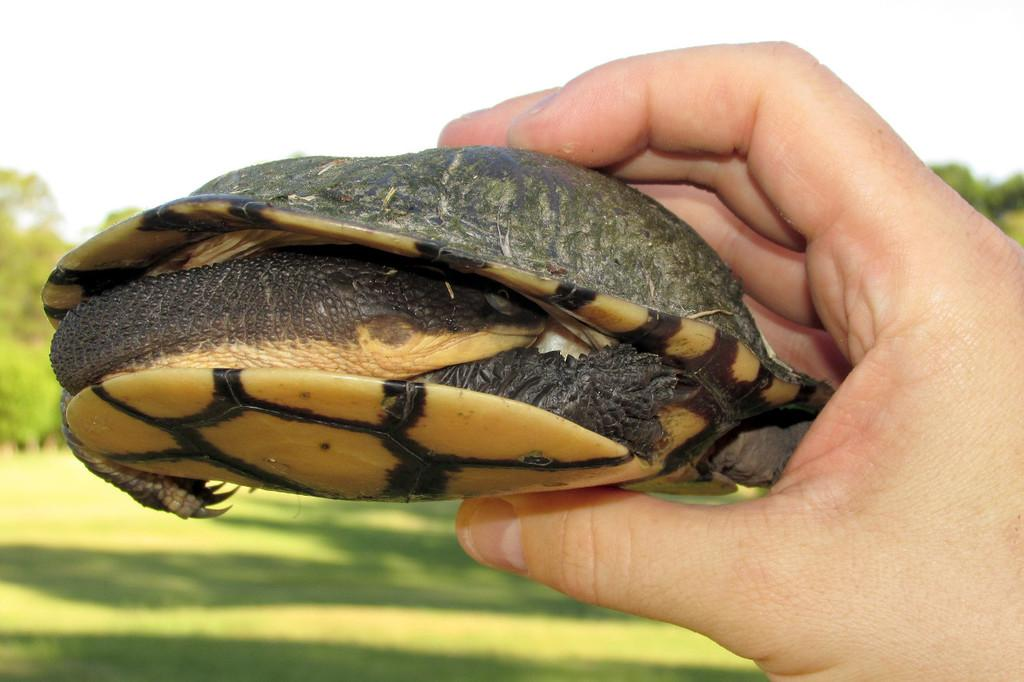Who or what is the main subject in the image? There is a person in the image. What is the person holding in the image? The person is holding a turtle. What can be seen in the background of the image? There are trees and the sky visible in the background of the image. What type of surface is visible in the image? The ground is visible in the image. What type of street can be seen in the image? There is no street present in the image; it features a person holding a turtle with trees and the sky visible in the background. 